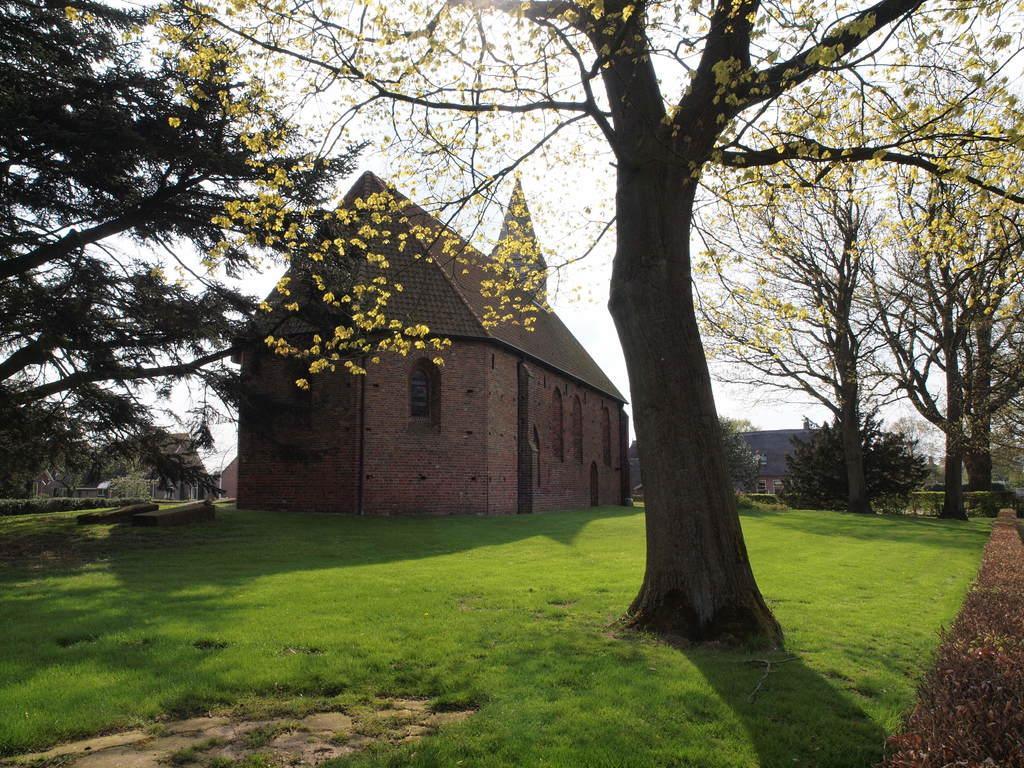Can you describe this image briefly? In this image I can see few trees in green color. In the background I can see few buildings and the sky is in white color. 